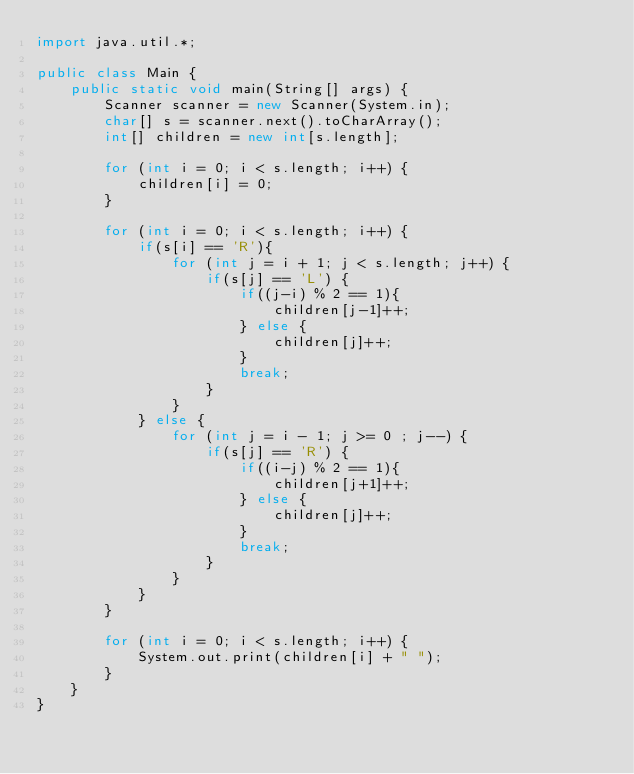Convert code to text. <code><loc_0><loc_0><loc_500><loc_500><_Java_>import java.util.*;

public class Main {
    public static void main(String[] args) {
        Scanner scanner = new Scanner(System.in);
        char[] s = scanner.next().toCharArray();
        int[] children = new int[s.length];

        for (int i = 0; i < s.length; i++) {
            children[i] = 0;
        }

        for (int i = 0; i < s.length; i++) {
            if(s[i] == 'R'){
                for (int j = i + 1; j < s.length; j++) {
                    if(s[j] == 'L') {
                        if((j-i) % 2 == 1){
                            children[j-1]++;
                        } else {
                            children[j]++;
                        }
                        break;
                    }
                }
            } else {
                for (int j = i - 1; j >= 0 ; j--) {
                    if(s[j] == 'R') {
                        if((i-j) % 2 == 1){
                            children[j+1]++;
                        } else {
                            children[j]++;
                        }
                        break;
                    }
                }
            }
        }

        for (int i = 0; i < s.length; i++) {
            System.out.print(children[i] + " ");
        }
    }
}

</code> 